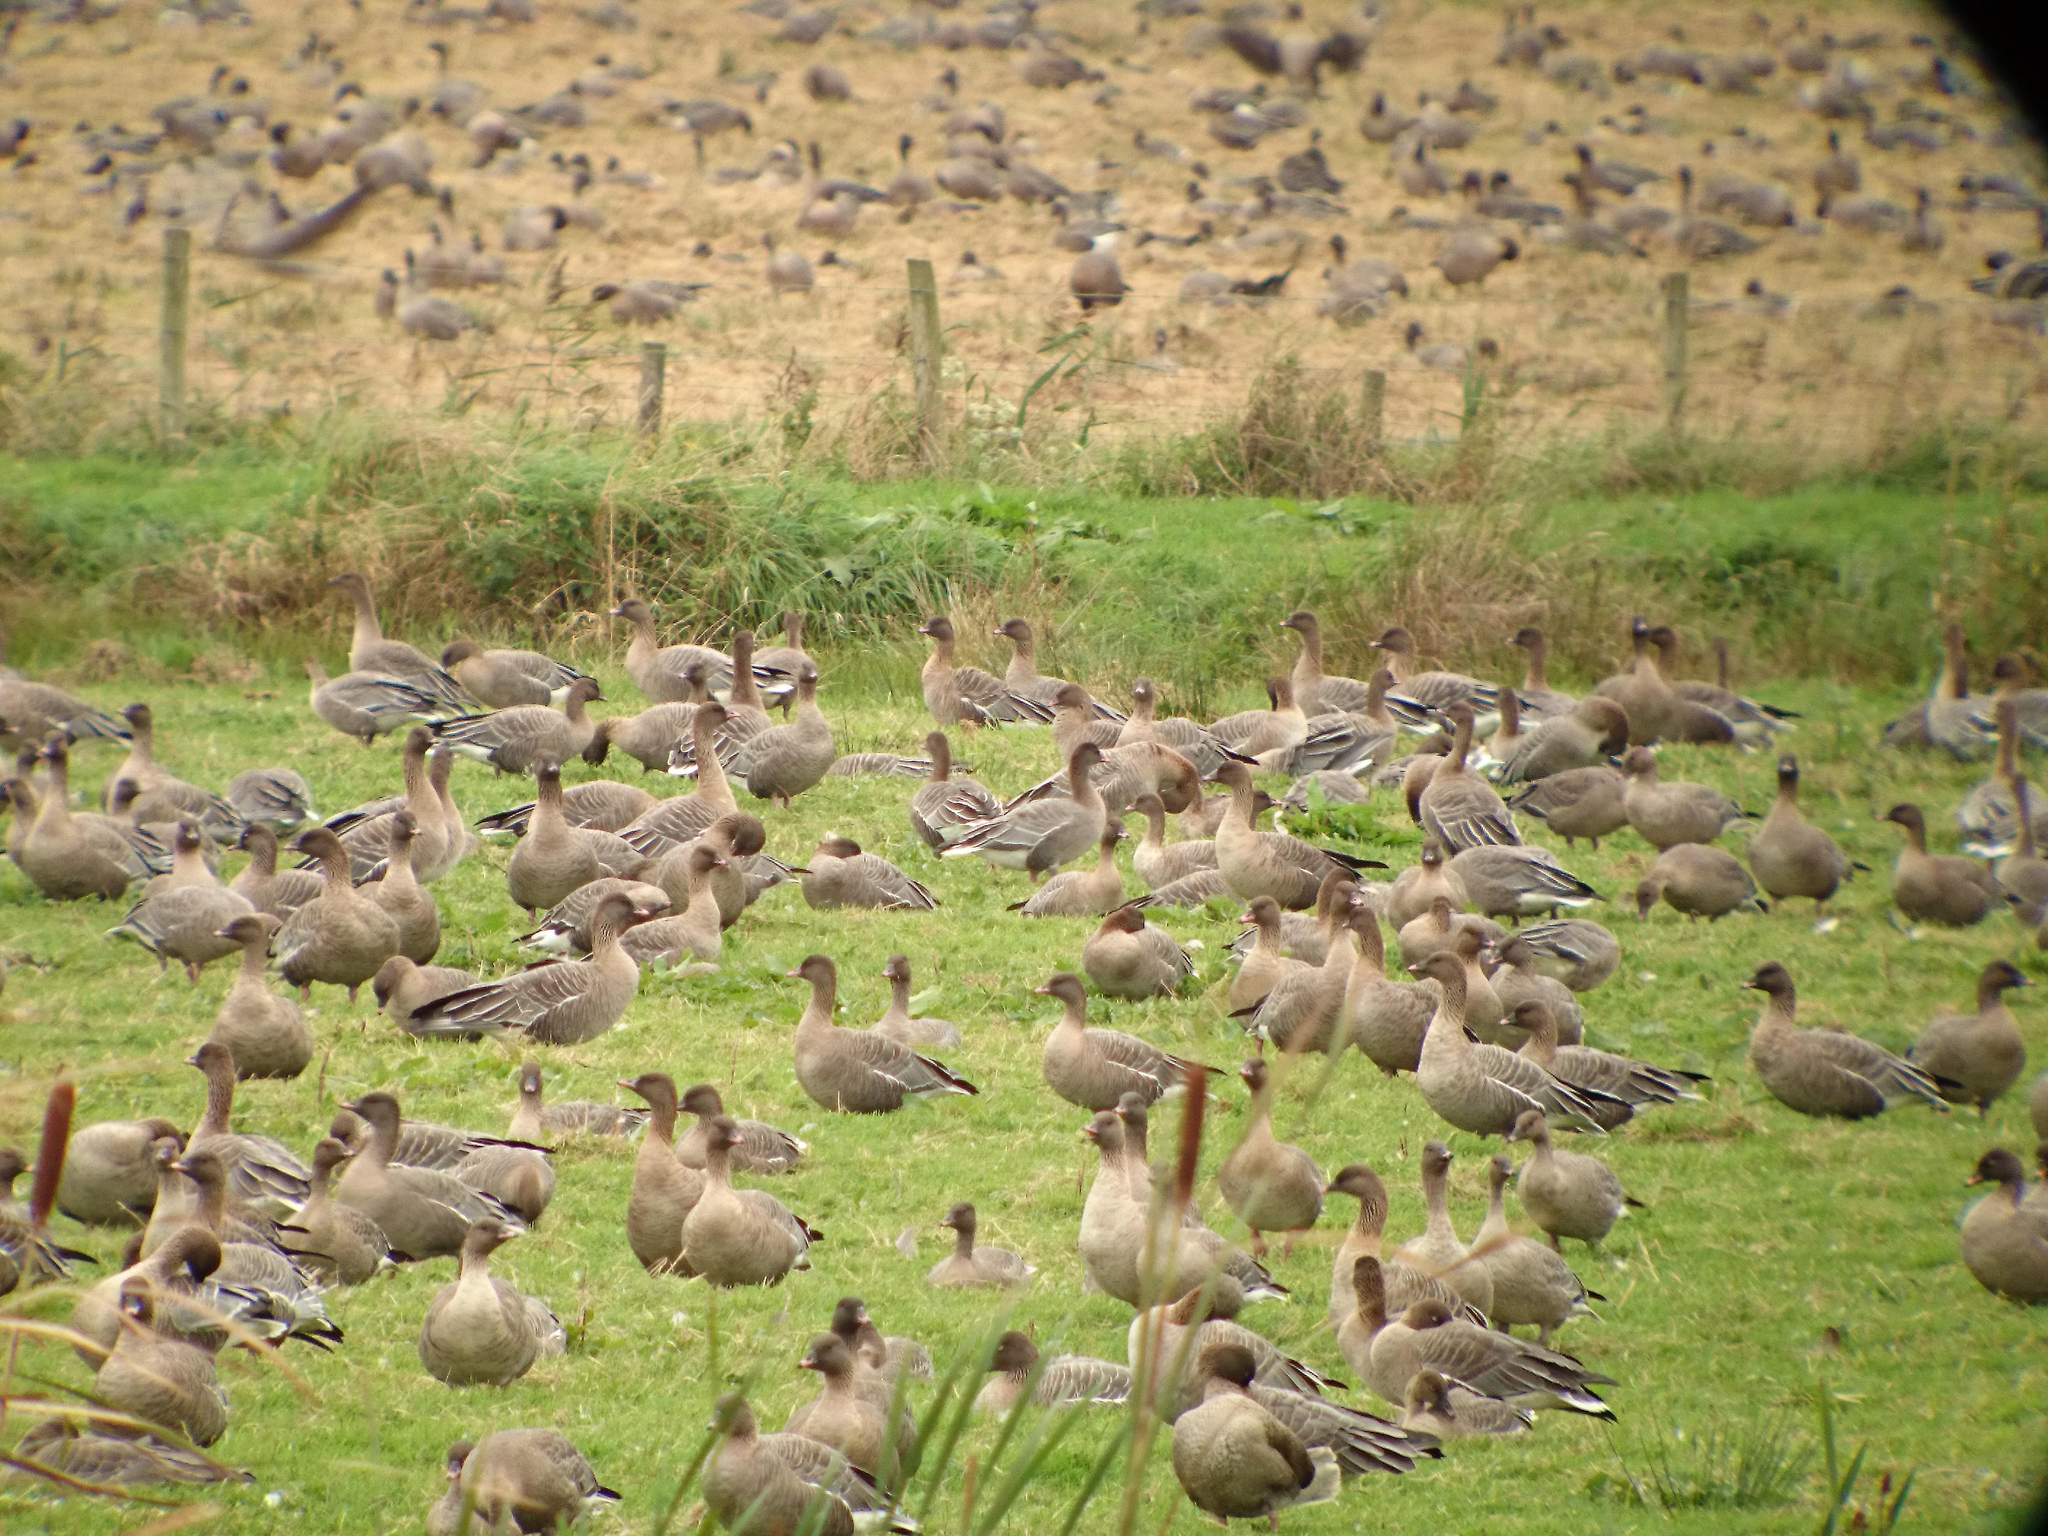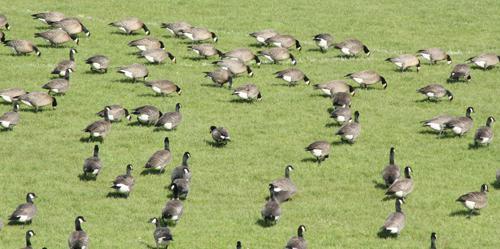The first image is the image on the left, the second image is the image on the right. Analyze the images presented: Is the assertion "There are more birds in the right image than in the left." valid? Answer yes or no. No. 